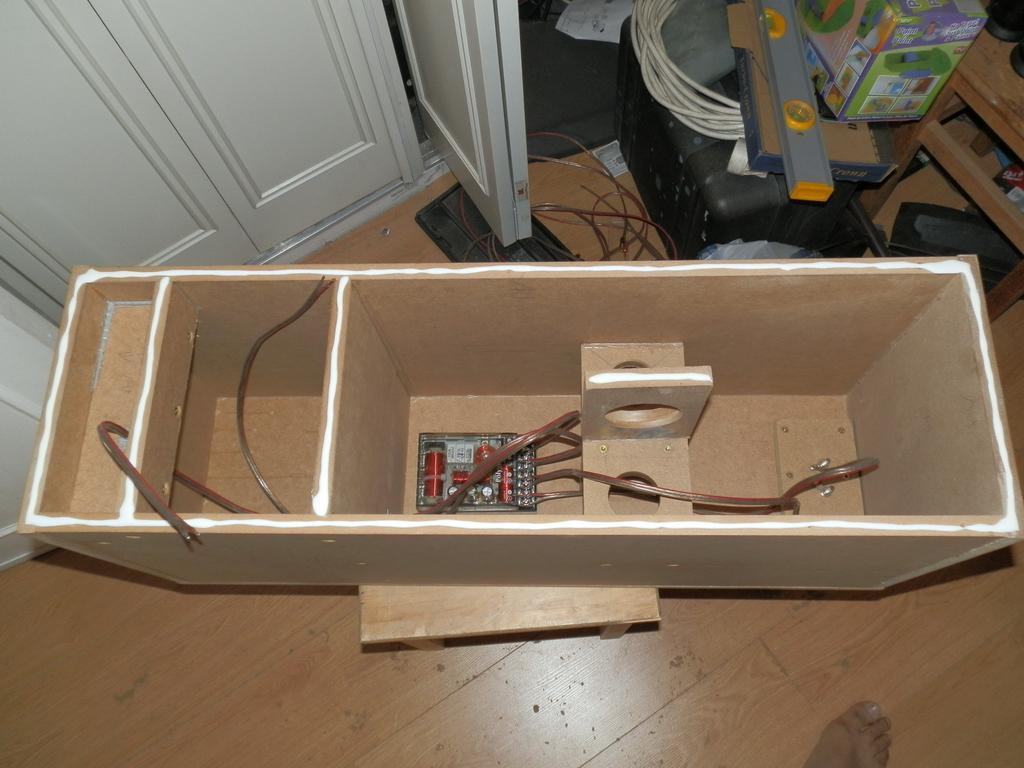Could you give a brief overview of what you see in this image? In this picture we can see a plywood box in the front, there is a wire and an integrated circuit present in the box, on the right side there are two boxes and wires, we can see cupboards at the top of the picture. 